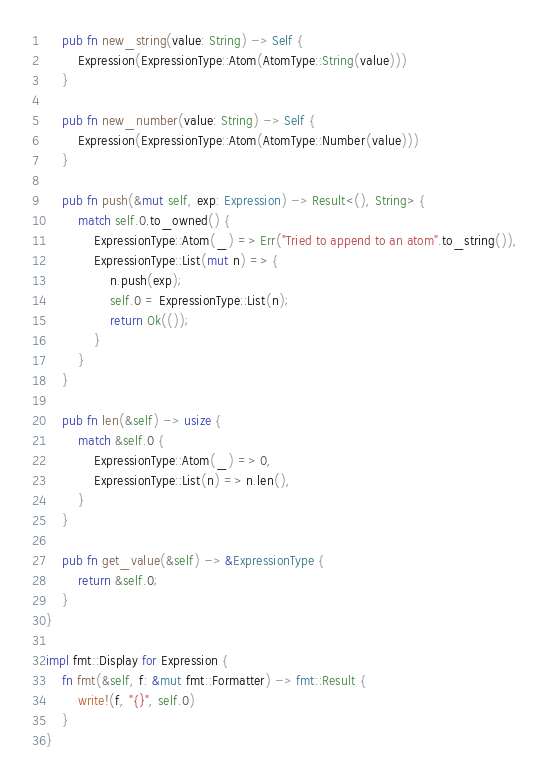Convert code to text. <code><loc_0><loc_0><loc_500><loc_500><_Rust_>    pub fn new_string(value: String) -> Self {
        Expression(ExpressionType::Atom(AtomType::String(value)))
    }

    pub fn new_number(value: String) -> Self {
        Expression(ExpressionType::Atom(AtomType::Number(value)))
    }

    pub fn push(&mut self, exp: Expression) -> Result<(), String> {
        match self.0.to_owned() {
            ExpressionType::Atom(_) => Err("Tried to append to an atom".to_string()),
            ExpressionType::List(mut n) => {
                n.push(exp);
                self.0 = ExpressionType::List(n);
                return Ok(());
            }
        }
    }

    pub fn len(&self) -> usize {
        match &self.0 {
            ExpressionType::Atom(_) => 0,
            ExpressionType::List(n) => n.len(),
        }
    }

    pub fn get_value(&self) -> &ExpressionType {
        return &self.0;
    }
}

impl fmt::Display for Expression {
    fn fmt(&self, f: &mut fmt::Formatter) -> fmt::Result {
        write!(f, "{}", self.0)
    }
}
</code> 